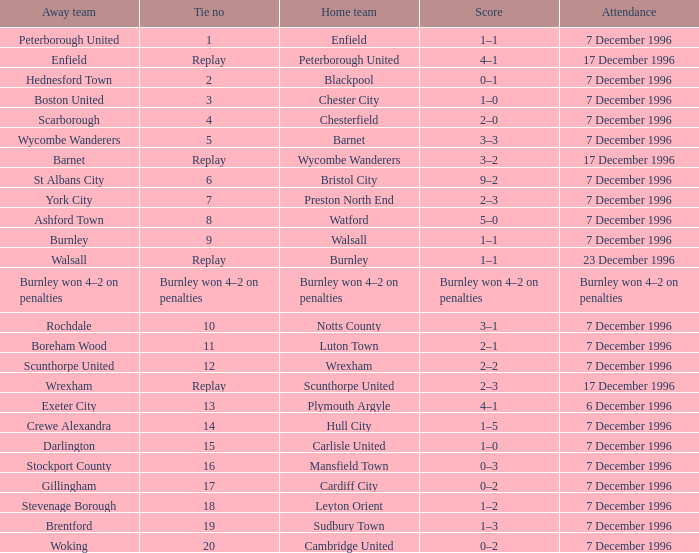What was the score of tie number 15? 1–0. 